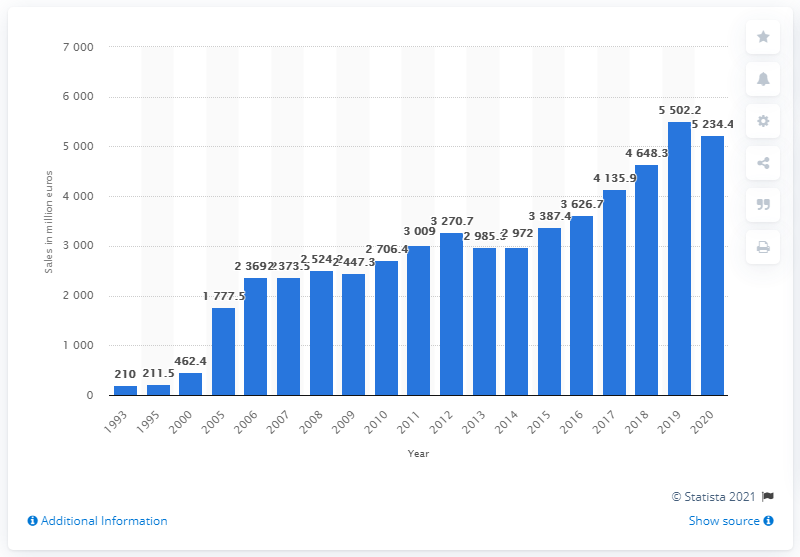Point out several critical features in this image. Puma's sales revenues have grown by 2524.2% since 2014. In 2020, Puma's worldwide sales of footwear, apparel, and accessories generated a total revenue of 5234.4 million dollars. 